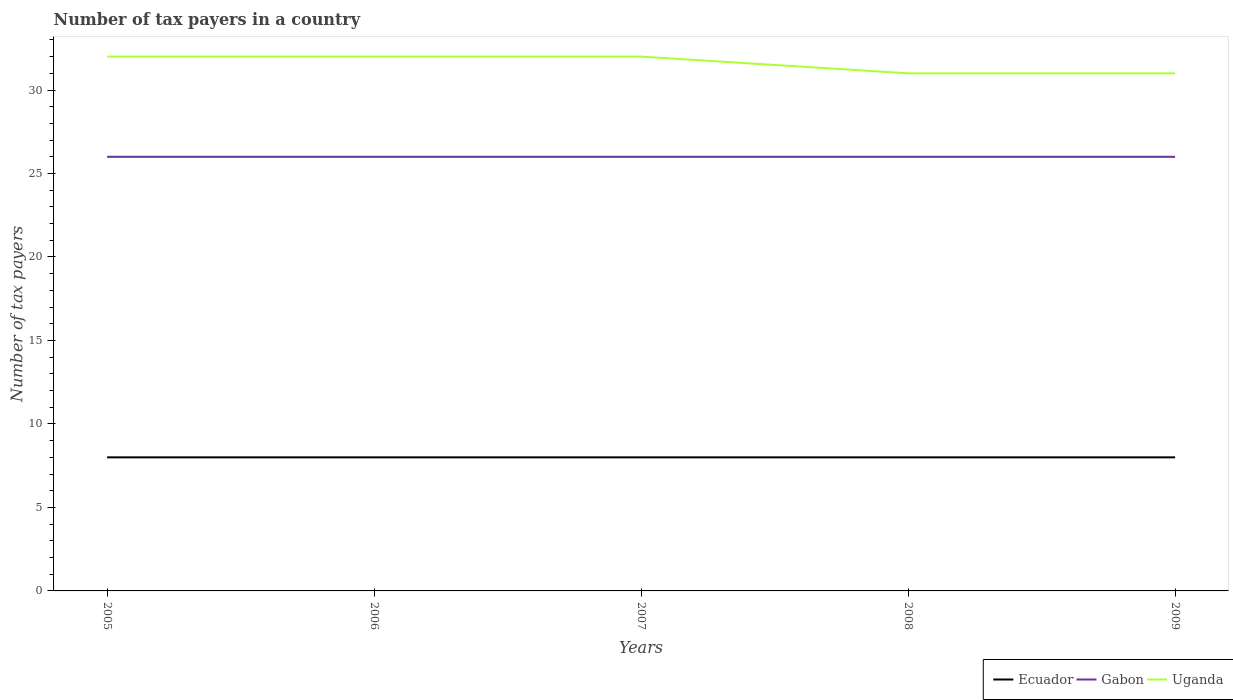Does the line corresponding to Gabon intersect with the line corresponding to Uganda?
Give a very brief answer. No. Is the number of lines equal to the number of legend labels?
Your answer should be compact. Yes. Across all years, what is the maximum number of tax payers in in Ecuador?
Ensure brevity in your answer.  8. What is the total number of tax payers in in Gabon in the graph?
Offer a terse response. 0. What is the difference between the highest and the lowest number of tax payers in in Gabon?
Offer a very short reply. 0. Is the number of tax payers in in Uganda strictly greater than the number of tax payers in in Ecuador over the years?
Ensure brevity in your answer.  No. Where does the legend appear in the graph?
Offer a terse response. Bottom right. What is the title of the graph?
Your answer should be compact. Number of tax payers in a country. What is the label or title of the Y-axis?
Make the answer very short. Number of tax payers. What is the Number of tax payers of Ecuador in 2005?
Give a very brief answer. 8. What is the Number of tax payers in Uganda in 2005?
Offer a terse response. 32. What is the Number of tax payers in Uganda in 2006?
Keep it short and to the point. 32. What is the Number of tax payers of Ecuador in 2007?
Make the answer very short. 8. What is the Number of tax payers in Uganda in 2007?
Provide a succinct answer. 32. What is the Number of tax payers in Ecuador in 2008?
Ensure brevity in your answer.  8. What is the Number of tax payers in Gabon in 2008?
Ensure brevity in your answer.  26. What is the Number of tax payers in Uganda in 2008?
Ensure brevity in your answer.  31. What is the Number of tax payers of Ecuador in 2009?
Keep it short and to the point. 8. What is the Number of tax payers of Uganda in 2009?
Ensure brevity in your answer.  31. Across all years, what is the maximum Number of tax payers of Ecuador?
Your answer should be very brief. 8. Across all years, what is the minimum Number of tax payers in Ecuador?
Keep it short and to the point. 8. Across all years, what is the minimum Number of tax payers of Gabon?
Your answer should be compact. 26. What is the total Number of tax payers of Gabon in the graph?
Give a very brief answer. 130. What is the total Number of tax payers in Uganda in the graph?
Give a very brief answer. 158. What is the difference between the Number of tax payers of Gabon in 2005 and that in 2006?
Offer a very short reply. 0. What is the difference between the Number of tax payers in Uganda in 2005 and that in 2006?
Ensure brevity in your answer.  0. What is the difference between the Number of tax payers of Ecuador in 2005 and that in 2007?
Keep it short and to the point. 0. What is the difference between the Number of tax payers in Gabon in 2005 and that in 2007?
Your response must be concise. 0. What is the difference between the Number of tax payers in Ecuador in 2005 and that in 2008?
Offer a terse response. 0. What is the difference between the Number of tax payers in Gabon in 2005 and that in 2008?
Make the answer very short. 0. What is the difference between the Number of tax payers of Uganda in 2005 and that in 2008?
Provide a succinct answer. 1. What is the difference between the Number of tax payers in Ecuador in 2006 and that in 2007?
Your response must be concise. 0. What is the difference between the Number of tax payers of Gabon in 2006 and that in 2007?
Provide a short and direct response. 0. What is the difference between the Number of tax payers in Ecuador in 2006 and that in 2008?
Provide a succinct answer. 0. What is the difference between the Number of tax payers of Uganda in 2006 and that in 2008?
Offer a terse response. 1. What is the difference between the Number of tax payers of Ecuador in 2006 and that in 2009?
Offer a very short reply. 0. What is the difference between the Number of tax payers in Uganda in 2007 and that in 2008?
Your response must be concise. 1. What is the difference between the Number of tax payers of Ecuador in 2007 and that in 2009?
Your response must be concise. 0. What is the difference between the Number of tax payers of Gabon in 2007 and that in 2009?
Give a very brief answer. 0. What is the difference between the Number of tax payers of Gabon in 2008 and that in 2009?
Offer a very short reply. 0. What is the difference between the Number of tax payers of Uganda in 2008 and that in 2009?
Offer a very short reply. 0. What is the difference between the Number of tax payers in Ecuador in 2005 and the Number of tax payers in Gabon in 2006?
Make the answer very short. -18. What is the difference between the Number of tax payers in Ecuador in 2005 and the Number of tax payers in Uganda in 2006?
Provide a short and direct response. -24. What is the difference between the Number of tax payers in Gabon in 2005 and the Number of tax payers in Uganda in 2006?
Provide a succinct answer. -6. What is the difference between the Number of tax payers in Ecuador in 2005 and the Number of tax payers in Gabon in 2007?
Provide a succinct answer. -18. What is the difference between the Number of tax payers of Ecuador in 2005 and the Number of tax payers of Uganda in 2007?
Your response must be concise. -24. What is the difference between the Number of tax payers of Ecuador in 2005 and the Number of tax payers of Gabon in 2008?
Make the answer very short. -18. What is the difference between the Number of tax payers of Ecuador in 2006 and the Number of tax payers of Gabon in 2007?
Give a very brief answer. -18. What is the difference between the Number of tax payers in Gabon in 2006 and the Number of tax payers in Uganda in 2007?
Your response must be concise. -6. What is the difference between the Number of tax payers of Ecuador in 2006 and the Number of tax payers of Gabon in 2008?
Offer a very short reply. -18. What is the difference between the Number of tax payers of Ecuador in 2006 and the Number of tax payers of Uganda in 2008?
Provide a short and direct response. -23. What is the difference between the Number of tax payers in Gabon in 2006 and the Number of tax payers in Uganda in 2008?
Your response must be concise. -5. What is the difference between the Number of tax payers of Ecuador in 2006 and the Number of tax payers of Gabon in 2009?
Your answer should be compact. -18. What is the difference between the Number of tax payers of Gabon in 2006 and the Number of tax payers of Uganda in 2009?
Your answer should be very brief. -5. What is the difference between the Number of tax payers of Ecuador in 2007 and the Number of tax payers of Gabon in 2008?
Offer a very short reply. -18. What is the difference between the Number of tax payers of Ecuador in 2007 and the Number of tax payers of Uganda in 2009?
Offer a very short reply. -23. What is the difference between the Number of tax payers of Ecuador in 2008 and the Number of tax payers of Uganda in 2009?
Your answer should be very brief. -23. What is the difference between the Number of tax payers in Gabon in 2008 and the Number of tax payers in Uganda in 2009?
Your response must be concise. -5. What is the average Number of tax payers in Ecuador per year?
Your answer should be very brief. 8. What is the average Number of tax payers of Gabon per year?
Provide a short and direct response. 26. What is the average Number of tax payers of Uganda per year?
Keep it short and to the point. 31.6. In the year 2006, what is the difference between the Number of tax payers in Ecuador and Number of tax payers in Gabon?
Provide a short and direct response. -18. In the year 2006, what is the difference between the Number of tax payers in Gabon and Number of tax payers in Uganda?
Provide a succinct answer. -6. In the year 2007, what is the difference between the Number of tax payers of Ecuador and Number of tax payers of Gabon?
Give a very brief answer. -18. In the year 2007, what is the difference between the Number of tax payers in Ecuador and Number of tax payers in Uganda?
Your answer should be compact. -24. In the year 2009, what is the difference between the Number of tax payers of Gabon and Number of tax payers of Uganda?
Provide a succinct answer. -5. What is the ratio of the Number of tax payers in Ecuador in 2005 to that in 2006?
Give a very brief answer. 1. What is the ratio of the Number of tax payers in Uganda in 2005 to that in 2006?
Ensure brevity in your answer.  1. What is the ratio of the Number of tax payers in Ecuador in 2005 to that in 2007?
Offer a terse response. 1. What is the ratio of the Number of tax payers of Gabon in 2005 to that in 2007?
Provide a succinct answer. 1. What is the ratio of the Number of tax payers of Ecuador in 2005 to that in 2008?
Ensure brevity in your answer.  1. What is the ratio of the Number of tax payers in Uganda in 2005 to that in 2008?
Provide a short and direct response. 1.03. What is the ratio of the Number of tax payers in Gabon in 2005 to that in 2009?
Your answer should be very brief. 1. What is the ratio of the Number of tax payers in Uganda in 2005 to that in 2009?
Offer a very short reply. 1.03. What is the ratio of the Number of tax payers of Uganda in 2006 to that in 2007?
Your answer should be very brief. 1. What is the ratio of the Number of tax payers of Ecuador in 2006 to that in 2008?
Ensure brevity in your answer.  1. What is the ratio of the Number of tax payers in Gabon in 2006 to that in 2008?
Offer a terse response. 1. What is the ratio of the Number of tax payers in Uganda in 2006 to that in 2008?
Make the answer very short. 1.03. What is the ratio of the Number of tax payers of Ecuador in 2006 to that in 2009?
Your answer should be very brief. 1. What is the ratio of the Number of tax payers in Gabon in 2006 to that in 2009?
Keep it short and to the point. 1. What is the ratio of the Number of tax payers of Uganda in 2006 to that in 2009?
Provide a short and direct response. 1.03. What is the ratio of the Number of tax payers in Gabon in 2007 to that in 2008?
Offer a very short reply. 1. What is the ratio of the Number of tax payers in Uganda in 2007 to that in 2008?
Make the answer very short. 1.03. What is the ratio of the Number of tax payers in Ecuador in 2007 to that in 2009?
Provide a succinct answer. 1. What is the ratio of the Number of tax payers of Uganda in 2007 to that in 2009?
Ensure brevity in your answer.  1.03. What is the ratio of the Number of tax payers of Ecuador in 2008 to that in 2009?
Provide a short and direct response. 1. What is the ratio of the Number of tax payers of Uganda in 2008 to that in 2009?
Keep it short and to the point. 1. What is the difference between the highest and the lowest Number of tax payers of Ecuador?
Offer a very short reply. 0. 